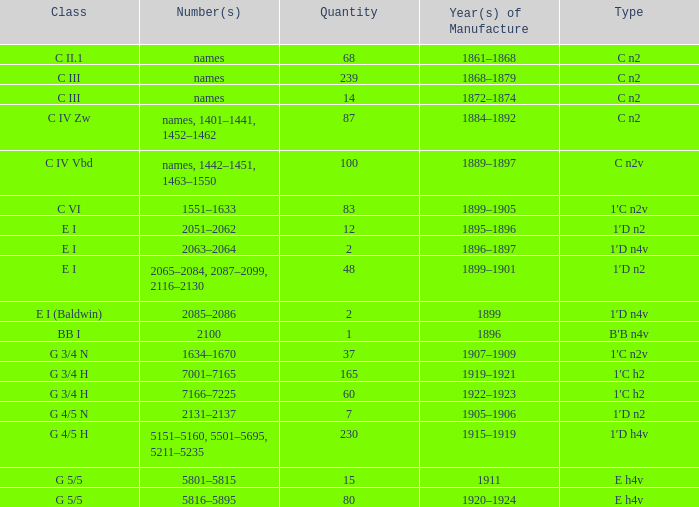Which category features a production year of 1899? E I (Baldwin). 